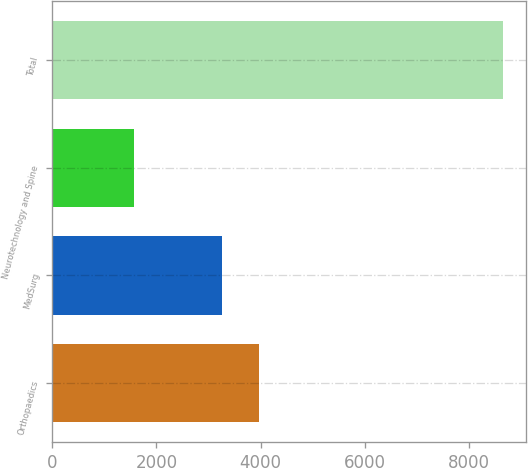Convert chart to OTSL. <chart><loc_0><loc_0><loc_500><loc_500><bar_chart><fcel>Orthopaedics<fcel>MedSurg<fcel>Neurotechnology and Spine<fcel>Total<nl><fcel>3973.8<fcel>3265<fcel>1569<fcel>8657<nl></chart> 